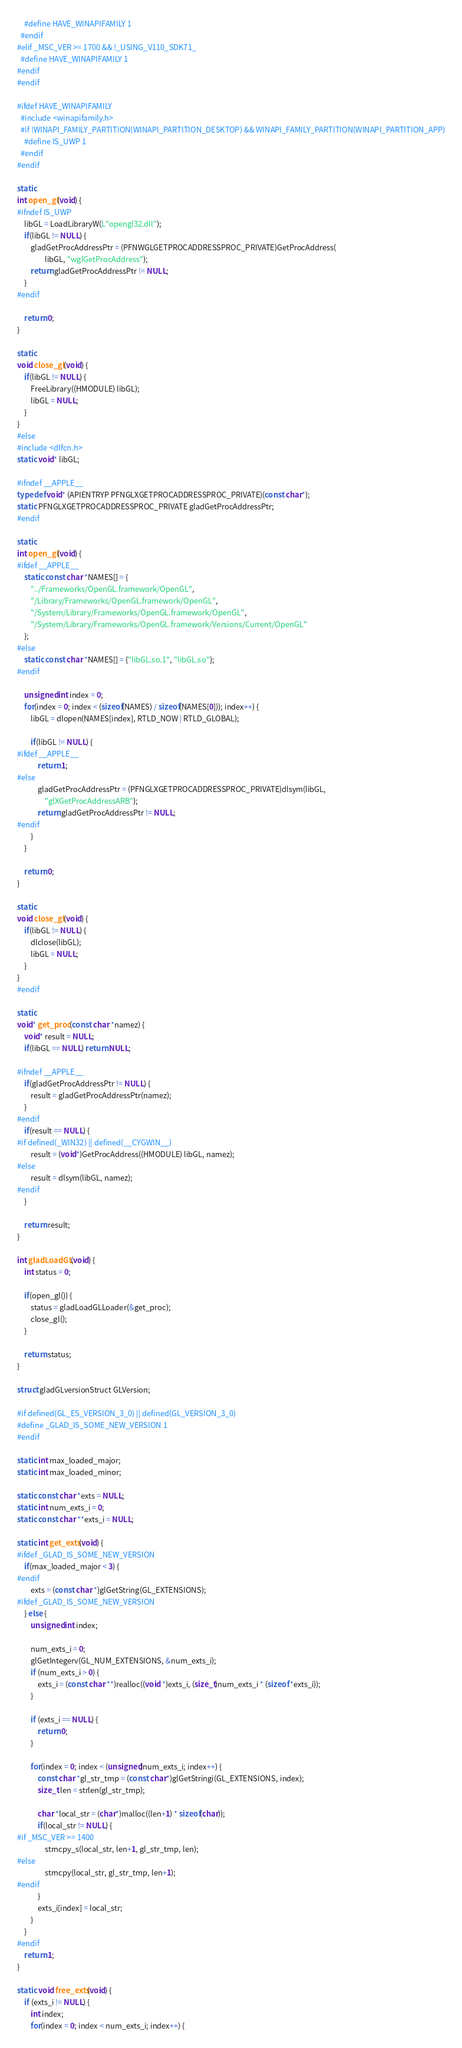Convert code to text. <code><loc_0><loc_0><loc_500><loc_500><_C++_>    #define HAVE_WINAPIFAMILY 1
  #endif
#elif _MSC_VER >= 1700 && !_USING_V110_SDK71_
  #define HAVE_WINAPIFAMILY 1
#endif
#endif

#ifdef HAVE_WINAPIFAMILY
  #include <winapifamily.h>
  #if !WINAPI_FAMILY_PARTITION(WINAPI_PARTITION_DESKTOP) && WINAPI_FAMILY_PARTITION(WINAPI_PARTITION_APP)
    #define IS_UWP 1
  #endif
#endif

static
int open_gl(void) {
#ifndef IS_UWP
    libGL = LoadLibraryW(L"opengl32.dll");
    if(libGL != NULL) {
        gladGetProcAddressPtr = (PFNWGLGETPROCADDRESSPROC_PRIVATE)GetProcAddress(
                libGL, "wglGetProcAddress");
        return gladGetProcAddressPtr != NULL;
    }
#endif

    return 0;
}

static
void close_gl(void) {
    if(libGL != NULL) {
        FreeLibrary((HMODULE) libGL);
        libGL = NULL;
    }
}
#else
#include <dlfcn.h>
static void* libGL;

#ifndef __APPLE__
typedef void* (APIENTRYP PFNGLXGETPROCADDRESSPROC_PRIVATE)(const char*);
static PFNGLXGETPROCADDRESSPROC_PRIVATE gladGetProcAddressPtr;
#endif

static
int open_gl(void) {
#ifdef __APPLE__
    static const char *NAMES[] = {
        "../Frameworks/OpenGL.framework/OpenGL",
        "/Library/Frameworks/OpenGL.framework/OpenGL",
        "/System/Library/Frameworks/OpenGL.framework/OpenGL",
        "/System/Library/Frameworks/OpenGL.framework/Versions/Current/OpenGL"
    };
#else
    static const char *NAMES[] = {"libGL.so.1", "libGL.so"};
#endif

    unsigned int index = 0;
    for(index = 0; index < (sizeof(NAMES) / sizeof(NAMES[0])); index++) {
        libGL = dlopen(NAMES[index], RTLD_NOW | RTLD_GLOBAL);

        if(libGL != NULL) {
#ifdef __APPLE__
            return 1;
#else
            gladGetProcAddressPtr = (PFNGLXGETPROCADDRESSPROC_PRIVATE)dlsym(libGL,
                "glXGetProcAddressARB");
            return gladGetProcAddressPtr != NULL;
#endif
        }
    }

    return 0;
}

static
void close_gl(void) {
    if(libGL != NULL) {
        dlclose(libGL);
        libGL = NULL;
    }
}
#endif

static
void* get_proc(const char *namez) {
    void* result = NULL;
    if(libGL == NULL) return NULL;

#ifndef __APPLE__
    if(gladGetProcAddressPtr != NULL) {
        result = gladGetProcAddressPtr(namez);
    }
#endif
    if(result == NULL) {
#if defined(_WIN32) || defined(__CYGWIN__)
        result = (void*)GetProcAddress((HMODULE) libGL, namez);
#else
        result = dlsym(libGL, namez);
#endif
    }

    return result;
}

int gladLoadGL(void) {
    int status = 0;

    if(open_gl()) {
        status = gladLoadGLLoader(&get_proc);
        close_gl();
    }

    return status;
}

struct gladGLversionStruct GLVersion;

#if defined(GL_ES_VERSION_3_0) || defined(GL_VERSION_3_0)
#define _GLAD_IS_SOME_NEW_VERSION 1
#endif

static int max_loaded_major;
static int max_loaded_minor;

static const char *exts = NULL;
static int num_exts_i = 0;
static const char **exts_i = NULL;

static int get_exts(void) {
#ifdef _GLAD_IS_SOME_NEW_VERSION
    if(max_loaded_major < 3) {
#endif
        exts = (const char *)glGetString(GL_EXTENSIONS);
#ifdef _GLAD_IS_SOME_NEW_VERSION
    } else {
        unsigned int index;

        num_exts_i = 0;
        glGetIntegerv(GL_NUM_EXTENSIONS, &num_exts_i);
        if (num_exts_i > 0) {
            exts_i = (const char **)realloc((void *)exts_i, (size_t)num_exts_i * (sizeof *exts_i));
        }

        if (exts_i == NULL) {
            return 0;
        }

        for(index = 0; index < (unsigned)num_exts_i; index++) {
            const char *gl_str_tmp = (const char*)glGetStringi(GL_EXTENSIONS, index);
            size_t len = strlen(gl_str_tmp);

            char *local_str = (char*)malloc((len+1) * sizeof(char));
            if(local_str != NULL) {
#if _MSC_VER >= 1400
                strncpy_s(local_str, len+1, gl_str_tmp, len);
#else
                strncpy(local_str, gl_str_tmp, len+1);
#endif
            }
            exts_i[index] = local_str;
        }
    }
#endif
    return 1;
}

static void free_exts(void) {
    if (exts_i != NULL) {
        int index;
        for(index = 0; index < num_exts_i; index++) {</code> 